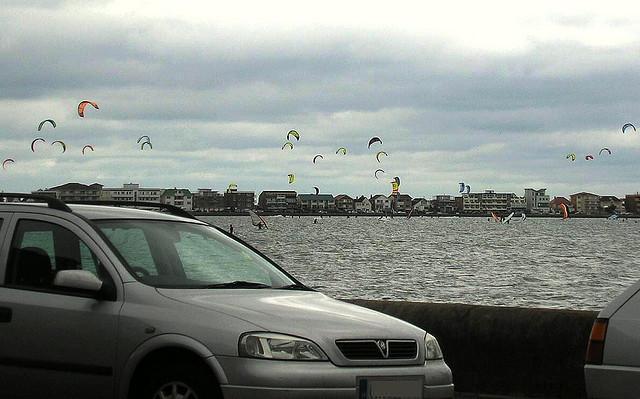How many cars can be seen?
Give a very brief answer. 2. How many white horses are there?
Give a very brief answer. 0. 